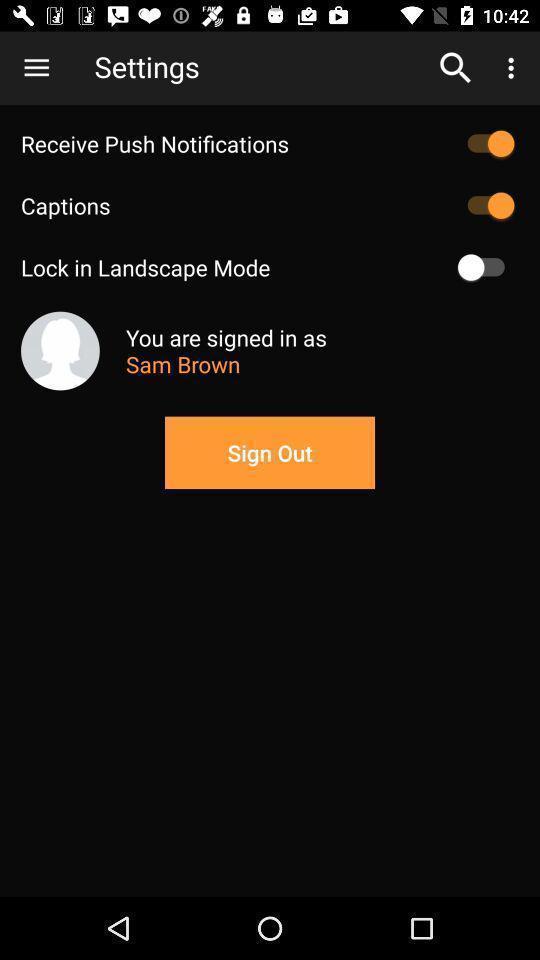Provide a textual representation of this image. Sign out page of an online entertaining app. 